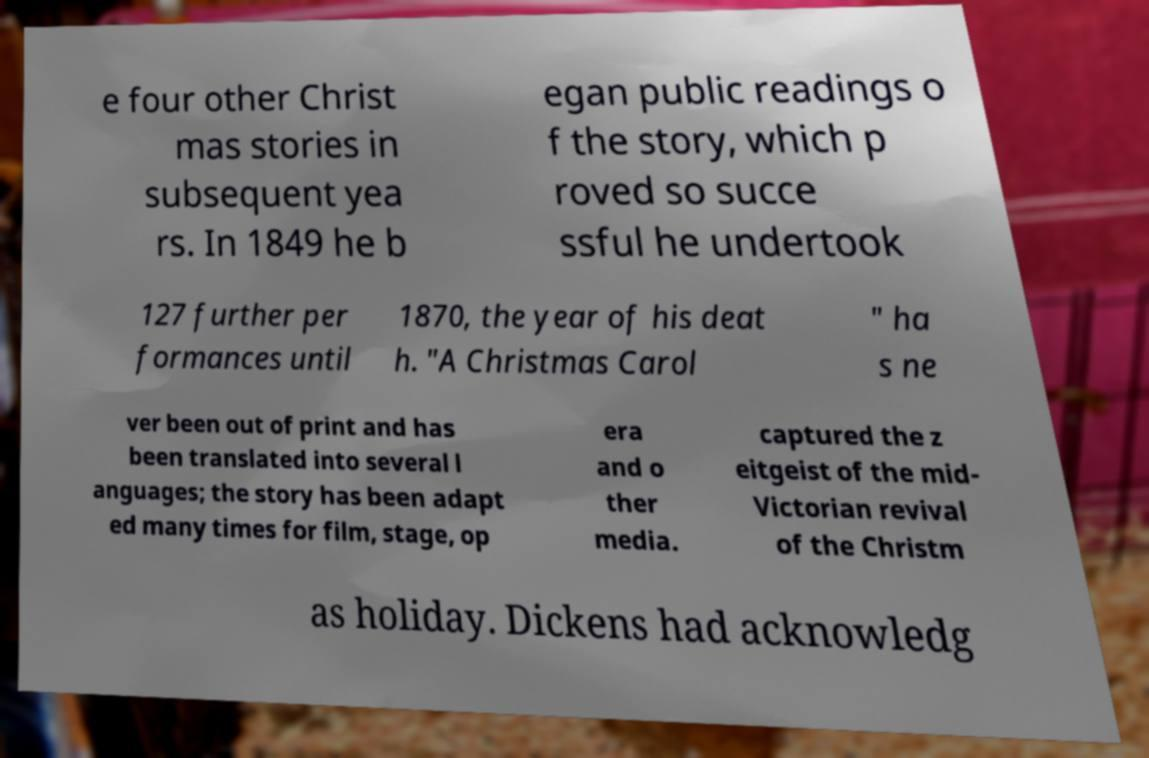Please read and relay the text visible in this image. What does it say? e four other Christ mas stories in subsequent yea rs. In 1849 he b egan public readings o f the story, which p roved so succe ssful he undertook 127 further per formances until 1870, the year of his deat h. "A Christmas Carol " ha s ne ver been out of print and has been translated into several l anguages; the story has been adapt ed many times for film, stage, op era and o ther media. captured the z eitgeist of the mid- Victorian revival of the Christm as holiday. Dickens had acknowledg 